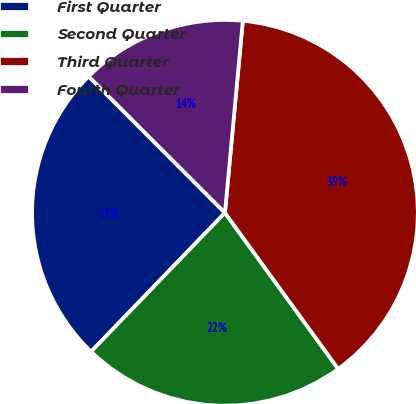Convert chart to OTSL. <chart><loc_0><loc_0><loc_500><loc_500><pie_chart><fcel>First Quarter<fcel>Second Quarter<fcel>Third Quarter<fcel>Fourth Quarter<nl><fcel>25.3%<fcel>22.2%<fcel>38.53%<fcel>13.97%<nl></chart> 